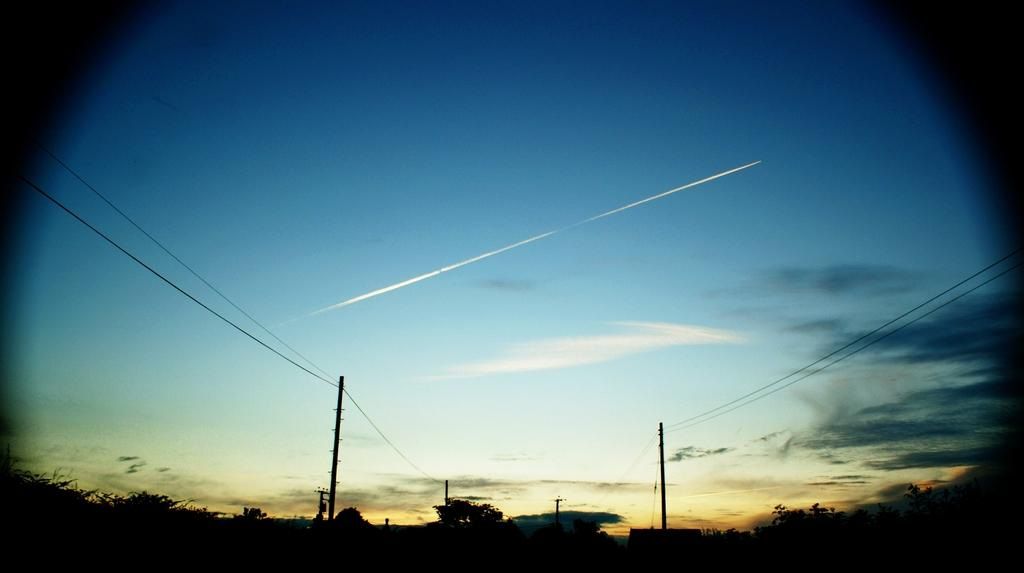What objects can be seen in the image? There are two poles in the image. What can be seen at the top of the image? The sky is visible at the top of the image, and it is blue. What type of vegetation is in the background of the image? There are trees in the background of the image. What type of can is hanging from one of the poles in the image? There is no can present in the image; it only features two poles and a blue sky in the background. What kind of creature can be seen interacting with the poles in the image? There is no creature present in the image; it only features two poles and a blue sky in the background. 